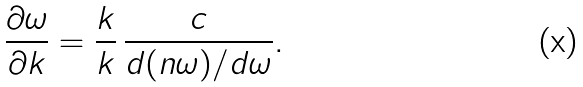Convert formula to latex. <formula><loc_0><loc_0><loc_500><loc_500>\frac { \partial \omega } { \partial k } = \frac { k } { k } \, \frac { c } { d ( n \omega ) / d \omega } .</formula> 